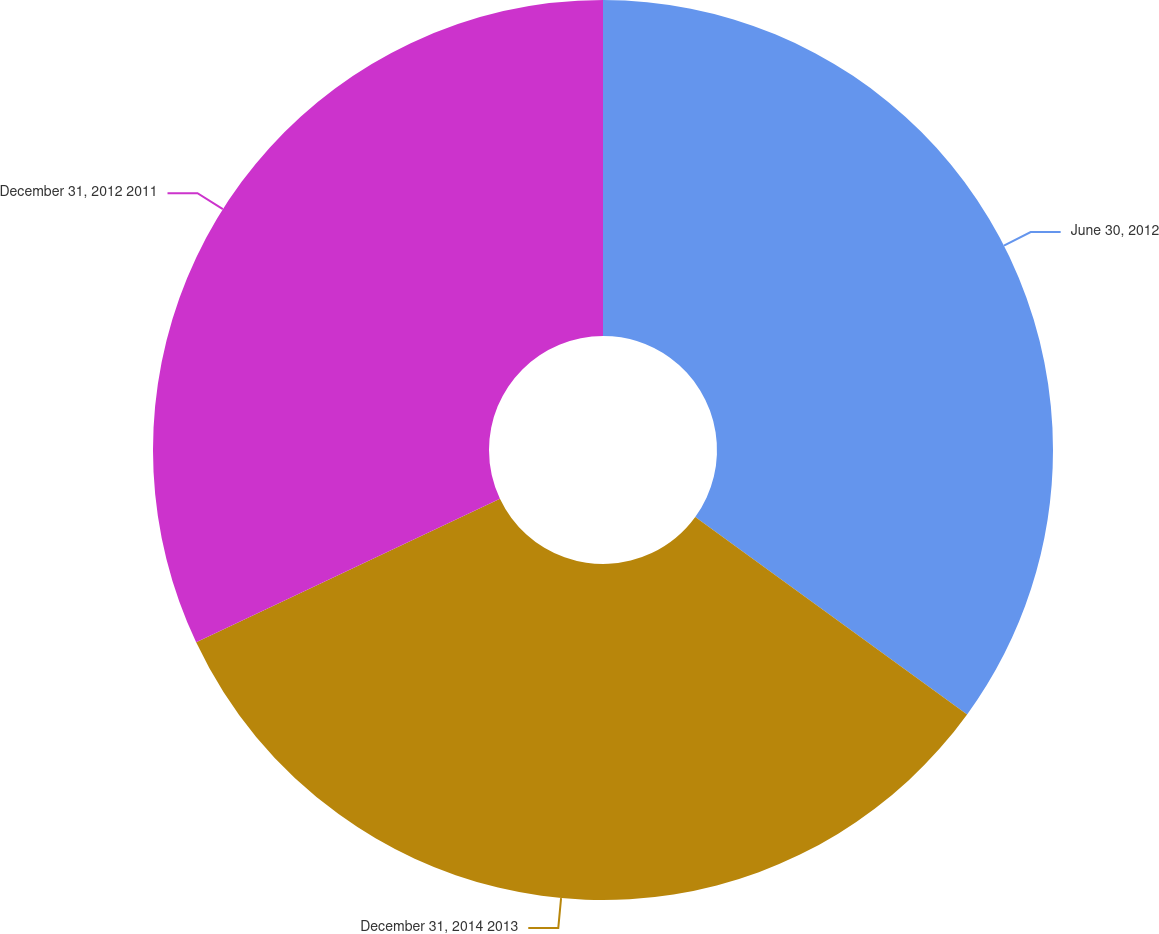Convert chart. <chart><loc_0><loc_0><loc_500><loc_500><pie_chart><fcel>June 30, 2012<fcel>December 31, 2014 2013<fcel>December 31, 2012 2011<nl><fcel>35.0%<fcel>32.98%<fcel>32.03%<nl></chart> 